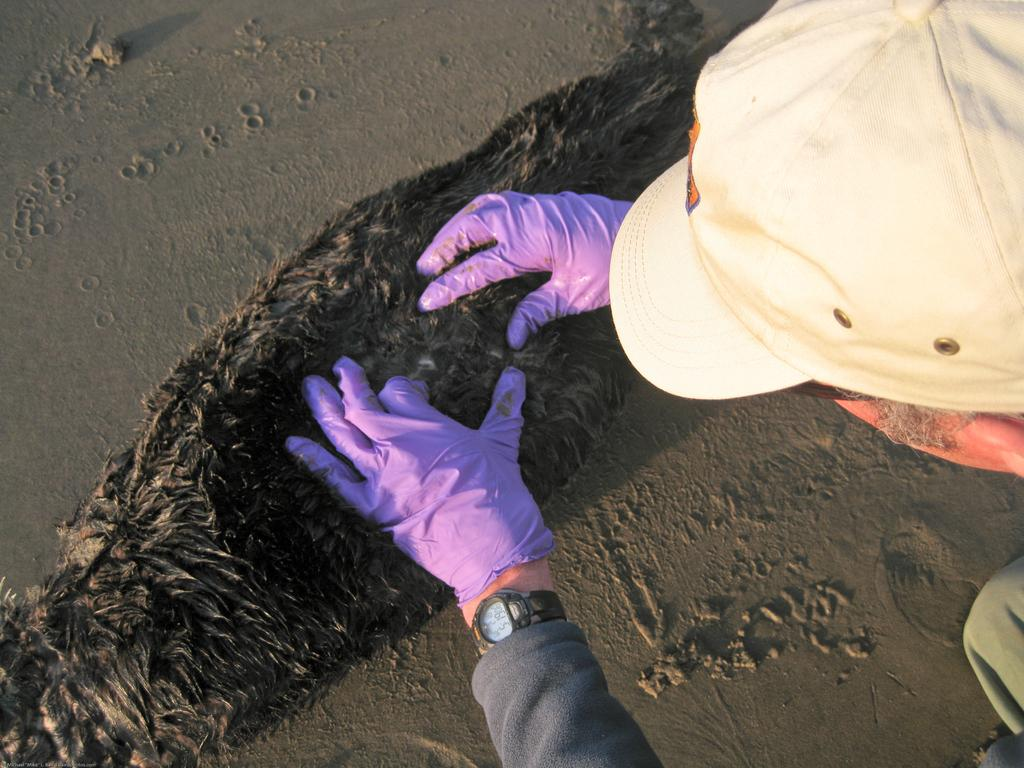Who is present in the image? There is a man in the image. What is the man wearing on his hands? The man is wearing gloves. What accessory can be seen on the man's wrist? The man has a watch on his hand. What is the man doing in the image? The man is interacting with an animal. What type of surface is the animal standing on? The animal is standing on sand. What type of cake is the man baking in the image? There is no cake present in the image, nor is the man engaged in any baking activity. 